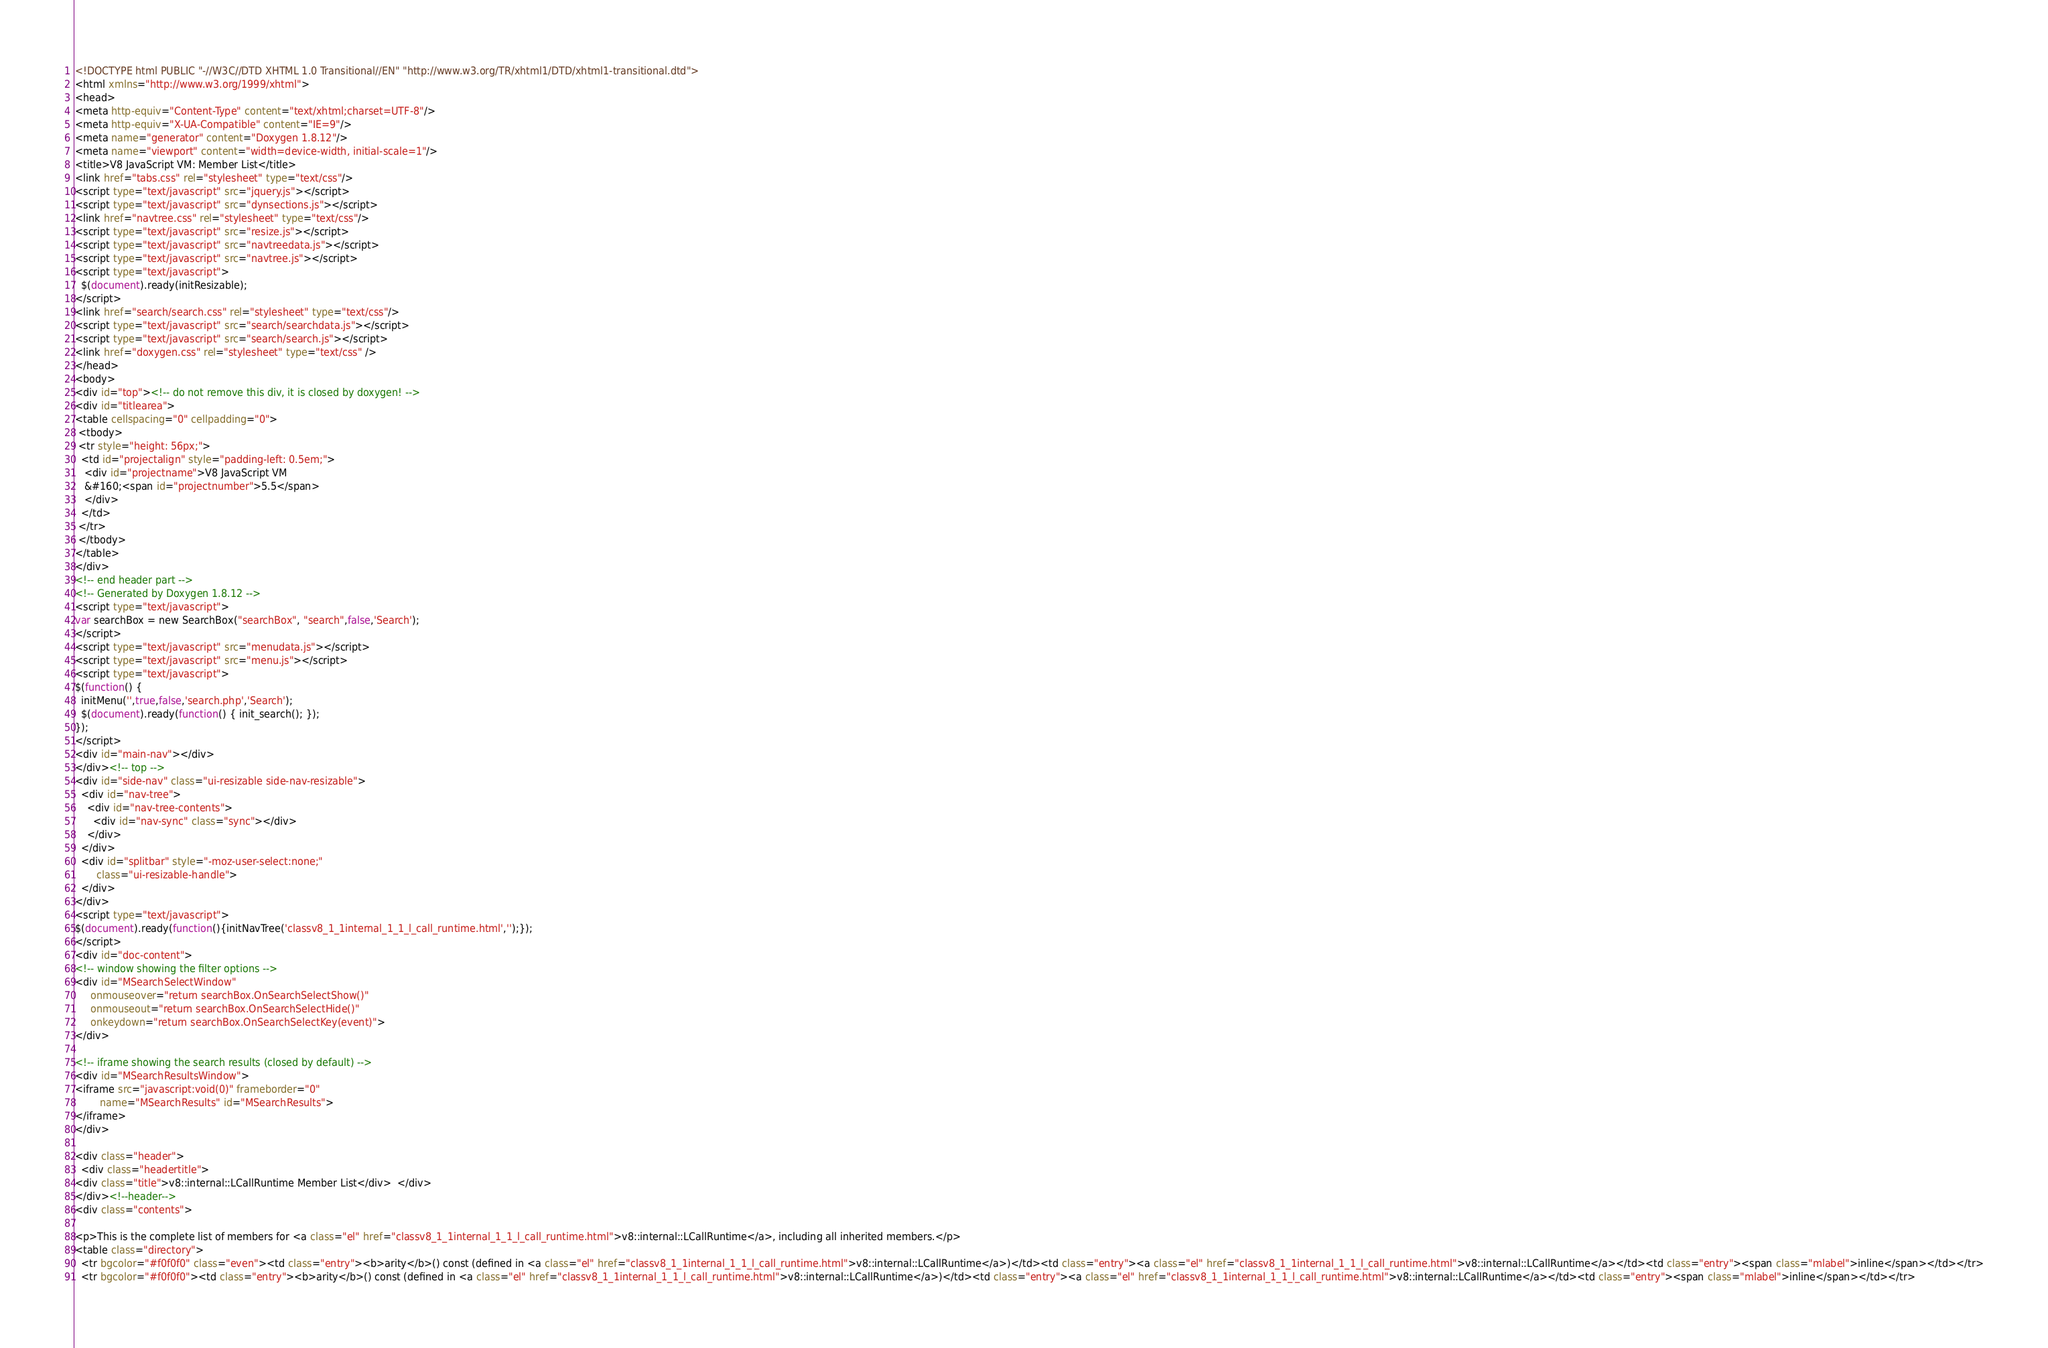<code> <loc_0><loc_0><loc_500><loc_500><_HTML_><!DOCTYPE html PUBLIC "-//W3C//DTD XHTML 1.0 Transitional//EN" "http://www.w3.org/TR/xhtml1/DTD/xhtml1-transitional.dtd">
<html xmlns="http://www.w3.org/1999/xhtml">
<head>
<meta http-equiv="Content-Type" content="text/xhtml;charset=UTF-8"/>
<meta http-equiv="X-UA-Compatible" content="IE=9"/>
<meta name="generator" content="Doxygen 1.8.12"/>
<meta name="viewport" content="width=device-width, initial-scale=1"/>
<title>V8 JavaScript VM: Member List</title>
<link href="tabs.css" rel="stylesheet" type="text/css"/>
<script type="text/javascript" src="jquery.js"></script>
<script type="text/javascript" src="dynsections.js"></script>
<link href="navtree.css" rel="stylesheet" type="text/css"/>
<script type="text/javascript" src="resize.js"></script>
<script type="text/javascript" src="navtreedata.js"></script>
<script type="text/javascript" src="navtree.js"></script>
<script type="text/javascript">
  $(document).ready(initResizable);
</script>
<link href="search/search.css" rel="stylesheet" type="text/css"/>
<script type="text/javascript" src="search/searchdata.js"></script>
<script type="text/javascript" src="search/search.js"></script>
<link href="doxygen.css" rel="stylesheet" type="text/css" />
</head>
<body>
<div id="top"><!-- do not remove this div, it is closed by doxygen! -->
<div id="titlearea">
<table cellspacing="0" cellpadding="0">
 <tbody>
 <tr style="height: 56px;">
  <td id="projectalign" style="padding-left: 0.5em;">
   <div id="projectname">V8 JavaScript VM
   &#160;<span id="projectnumber">5.5</span>
   </div>
  </td>
 </tr>
 </tbody>
</table>
</div>
<!-- end header part -->
<!-- Generated by Doxygen 1.8.12 -->
<script type="text/javascript">
var searchBox = new SearchBox("searchBox", "search",false,'Search');
</script>
<script type="text/javascript" src="menudata.js"></script>
<script type="text/javascript" src="menu.js"></script>
<script type="text/javascript">
$(function() {
  initMenu('',true,false,'search.php','Search');
  $(document).ready(function() { init_search(); });
});
</script>
<div id="main-nav"></div>
</div><!-- top -->
<div id="side-nav" class="ui-resizable side-nav-resizable">
  <div id="nav-tree">
    <div id="nav-tree-contents">
      <div id="nav-sync" class="sync"></div>
    </div>
  </div>
  <div id="splitbar" style="-moz-user-select:none;" 
       class="ui-resizable-handle">
  </div>
</div>
<script type="text/javascript">
$(document).ready(function(){initNavTree('classv8_1_1internal_1_1_l_call_runtime.html','');});
</script>
<div id="doc-content">
<!-- window showing the filter options -->
<div id="MSearchSelectWindow"
     onmouseover="return searchBox.OnSearchSelectShow()"
     onmouseout="return searchBox.OnSearchSelectHide()"
     onkeydown="return searchBox.OnSearchSelectKey(event)">
</div>

<!-- iframe showing the search results (closed by default) -->
<div id="MSearchResultsWindow">
<iframe src="javascript:void(0)" frameborder="0" 
        name="MSearchResults" id="MSearchResults">
</iframe>
</div>

<div class="header">
  <div class="headertitle">
<div class="title">v8::internal::LCallRuntime Member List</div>  </div>
</div><!--header-->
<div class="contents">

<p>This is the complete list of members for <a class="el" href="classv8_1_1internal_1_1_l_call_runtime.html">v8::internal::LCallRuntime</a>, including all inherited members.</p>
<table class="directory">
  <tr bgcolor="#f0f0f0" class="even"><td class="entry"><b>arity</b>() const (defined in <a class="el" href="classv8_1_1internal_1_1_l_call_runtime.html">v8::internal::LCallRuntime</a>)</td><td class="entry"><a class="el" href="classv8_1_1internal_1_1_l_call_runtime.html">v8::internal::LCallRuntime</a></td><td class="entry"><span class="mlabel">inline</span></td></tr>
  <tr bgcolor="#f0f0f0"><td class="entry"><b>arity</b>() const (defined in <a class="el" href="classv8_1_1internal_1_1_l_call_runtime.html">v8::internal::LCallRuntime</a>)</td><td class="entry"><a class="el" href="classv8_1_1internal_1_1_l_call_runtime.html">v8::internal::LCallRuntime</a></td><td class="entry"><span class="mlabel">inline</span></td></tr></code> 